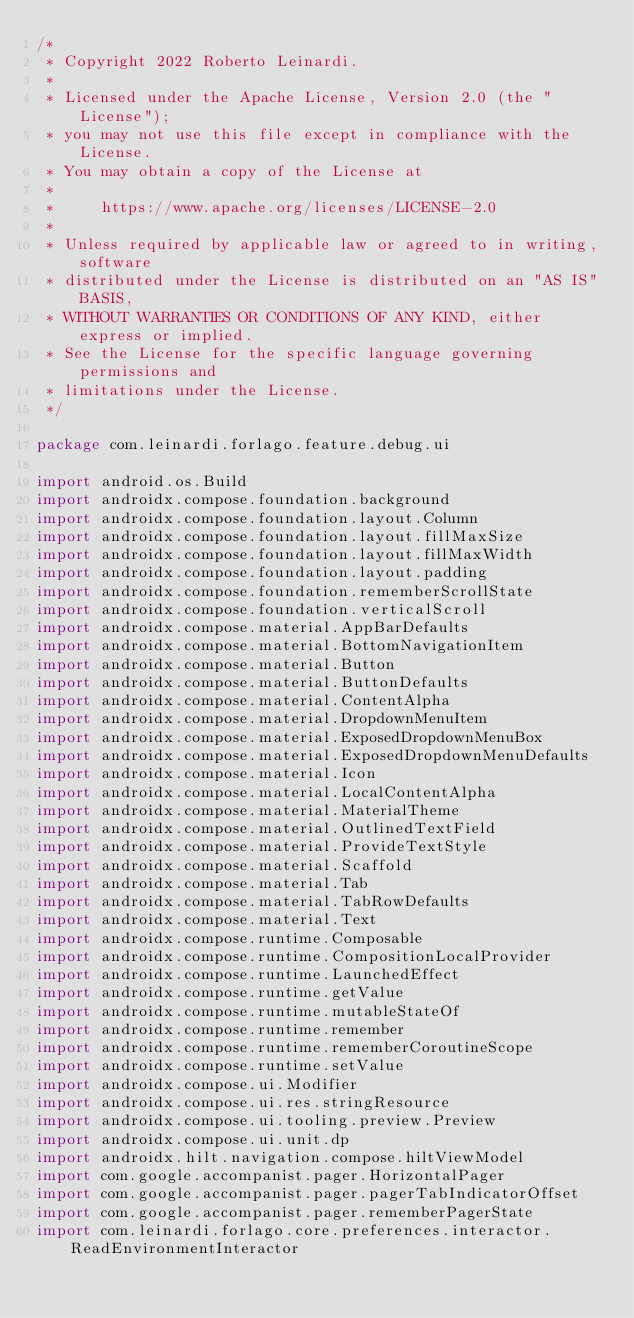Convert code to text. <code><loc_0><loc_0><loc_500><loc_500><_Kotlin_>/*
 * Copyright 2022 Roberto Leinardi.
 *
 * Licensed under the Apache License, Version 2.0 (the "License");
 * you may not use this file except in compliance with the License.
 * You may obtain a copy of the License at
 *
 *     https://www.apache.org/licenses/LICENSE-2.0
 *
 * Unless required by applicable law or agreed to in writing, software
 * distributed under the License is distributed on an "AS IS" BASIS,
 * WITHOUT WARRANTIES OR CONDITIONS OF ANY KIND, either express or implied.
 * See the License for the specific language governing permissions and
 * limitations under the License.
 */

package com.leinardi.forlago.feature.debug.ui

import android.os.Build
import androidx.compose.foundation.background
import androidx.compose.foundation.layout.Column
import androidx.compose.foundation.layout.fillMaxSize
import androidx.compose.foundation.layout.fillMaxWidth
import androidx.compose.foundation.layout.padding
import androidx.compose.foundation.rememberScrollState
import androidx.compose.foundation.verticalScroll
import androidx.compose.material.AppBarDefaults
import androidx.compose.material.BottomNavigationItem
import androidx.compose.material.Button
import androidx.compose.material.ButtonDefaults
import androidx.compose.material.ContentAlpha
import androidx.compose.material.DropdownMenuItem
import androidx.compose.material.ExposedDropdownMenuBox
import androidx.compose.material.ExposedDropdownMenuDefaults
import androidx.compose.material.Icon
import androidx.compose.material.LocalContentAlpha
import androidx.compose.material.MaterialTheme
import androidx.compose.material.OutlinedTextField
import androidx.compose.material.ProvideTextStyle
import androidx.compose.material.Scaffold
import androidx.compose.material.Tab
import androidx.compose.material.TabRowDefaults
import androidx.compose.material.Text
import androidx.compose.runtime.Composable
import androidx.compose.runtime.CompositionLocalProvider
import androidx.compose.runtime.LaunchedEffect
import androidx.compose.runtime.getValue
import androidx.compose.runtime.mutableStateOf
import androidx.compose.runtime.remember
import androidx.compose.runtime.rememberCoroutineScope
import androidx.compose.runtime.setValue
import androidx.compose.ui.Modifier
import androidx.compose.ui.res.stringResource
import androidx.compose.ui.tooling.preview.Preview
import androidx.compose.ui.unit.dp
import androidx.hilt.navigation.compose.hiltViewModel
import com.google.accompanist.pager.HorizontalPager
import com.google.accompanist.pager.pagerTabIndicatorOffset
import com.google.accompanist.pager.rememberPagerState
import com.leinardi.forlago.core.preferences.interactor.ReadEnvironmentInteractor</code> 